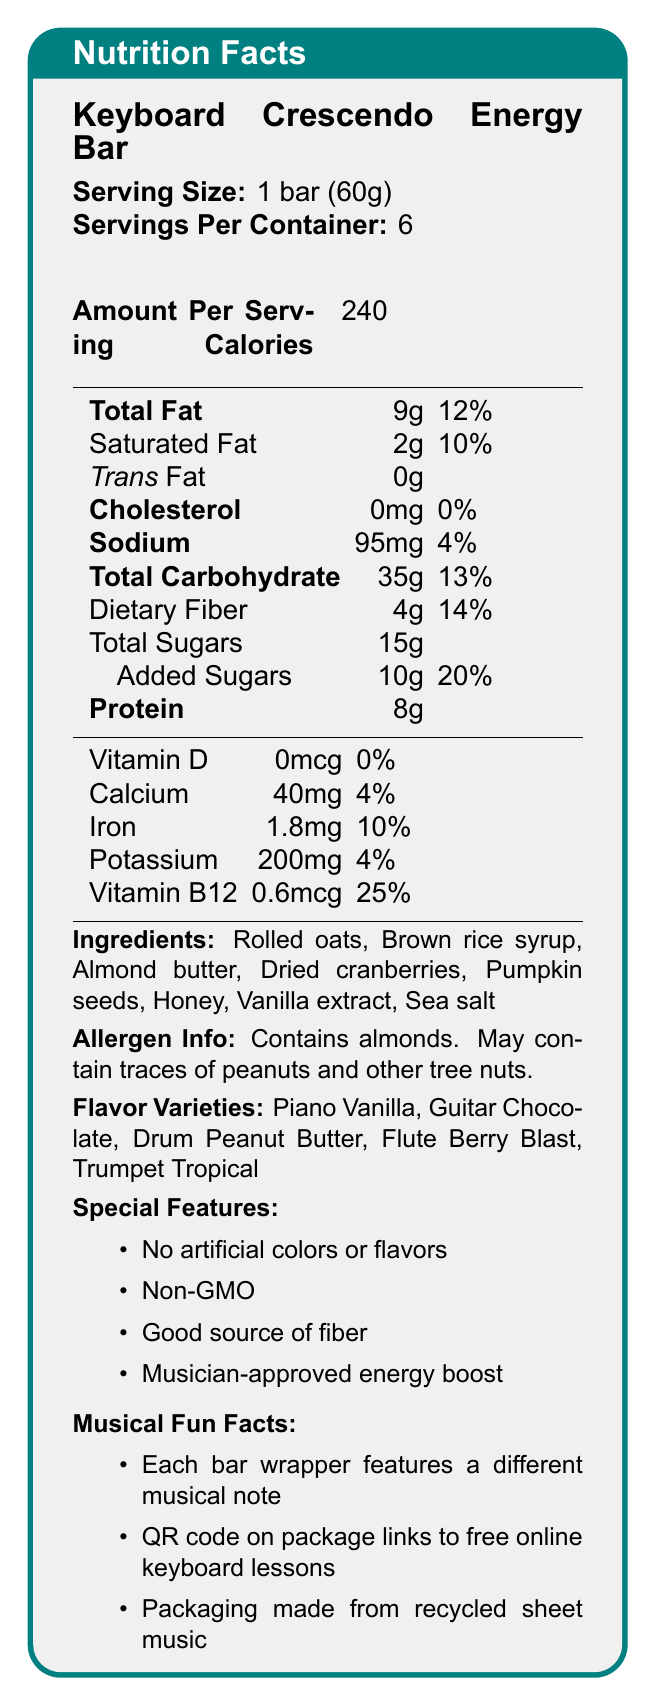what is the serving size for the Keyboard Crescendo Energy Bar? The document lists the serving size as "1 bar (60g)".
Answer: 1 bar (60g) how many bars are there in one container? The document states "Servings Per Container: 6".
Answer: 6 what is the total fat content in one serving? The document shows "Total Fat: 9g".
Answer: 9g name two flavor varieties of the Keyboard Crescendo Energy Bar. The document lists the flavor varieties as "Piano Vanilla, Guitar Chocolate, Drum Peanut Butter, Flute Berry Blast, Trumpet Tropical".
Answer: Piano Vanilla, Guitar Chocolate does the Keyboard Crescendo Energy Bar contain artificial colors or flavors? The document states as a feature "No artificial colors or flavors".
Answer: No what is the daily value percentage for vitamin B12? The document lists "Vitamin B12: 0.6mcg, 25%".
Answer: 25% what should you be cautious of if you have a tree nut allergy? The document's allergen info states "May contain traces of peanuts and other tree nuts".
Answer: May contain traces of peanuts and other tree nuts. how much dietary fiber does the bar contain? A. 2g B. 4g C. 6g D. 8g The document shows "Dietary Fiber: 4g".
Answer: B. 4g which musical fun fact is included in the document? A. Each bar wrapper features a different musical note B. The bar plays a tune when unwrapped C. The bar enhances musical performance D. The bar contains embedded sheet music The document under "Musical Fun Facts" states "Each bar wrapper features a different musical note".
Answer: A. Each bar wrapper features a different musical note is the Keyboard Crescendo Energy Bar considered Non-GMO? One of the special features listed is "Non-GMO".
Answer: Yes is there any trans fat in the Keyboard Crescendo Energy Bar? The document lists "Trans Fat: 0g".
Answer: No how many grams of protein are in one serving? The document shows "Protein: 8g".
Answer: 8g summarize the main points highlighted in the nutrition facts document. The document provides detailed nutrition information about the Keyboard Crescendo Energy Bar, including serving size, calorie content, and nutrient breakdown. It also emphasizes the bar's natural and Non-GMO ingredients, allergen info, variety of musical-themed flavors, and special features such as no artificial additives and environmental consciousness.
Answer: The Keyboard Crescendo Energy Bar contains 240 calories per bar, with key nutritional values such as 9g of total fat, 35g of carbohydrates, and 8g of protein. It features natural ingredients, comes in unique musical flavors, and includes musical fun facts like wrappers with musical notes and QR codes for keyboard lessons. It is Non-GMO, has no artificial colors or flavors, and is a good source of fiber while carry allergen information about almonds and potential traces of other tree nuts. how old is the brand Keyboard Crescendo? The document does not provide any details about the age or history of the brand.
Answer: Not enough information 